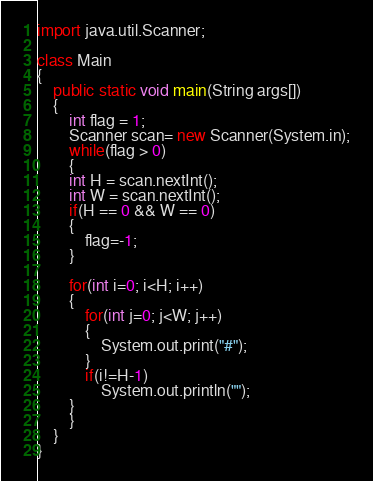<code> <loc_0><loc_0><loc_500><loc_500><_Java_>import java.util.Scanner;

class Main
{
	public static void main(String args[])
	{
		int flag = 1;
		Scanner scan= new Scanner(System.in);
		while(flag > 0)
		{
		int H = scan.nextInt();
		int W = scan.nextInt();
		if(H == 0 && W == 0)
		{
			flag=-1;
		}

		for(int i=0; i<H; i++)
		{
			for(int j=0; j<W; j++)
			{
				System.out.print("#");
			}
			if(i!=H-1)
				System.out.println("");
		}
		}
	}
}</code> 